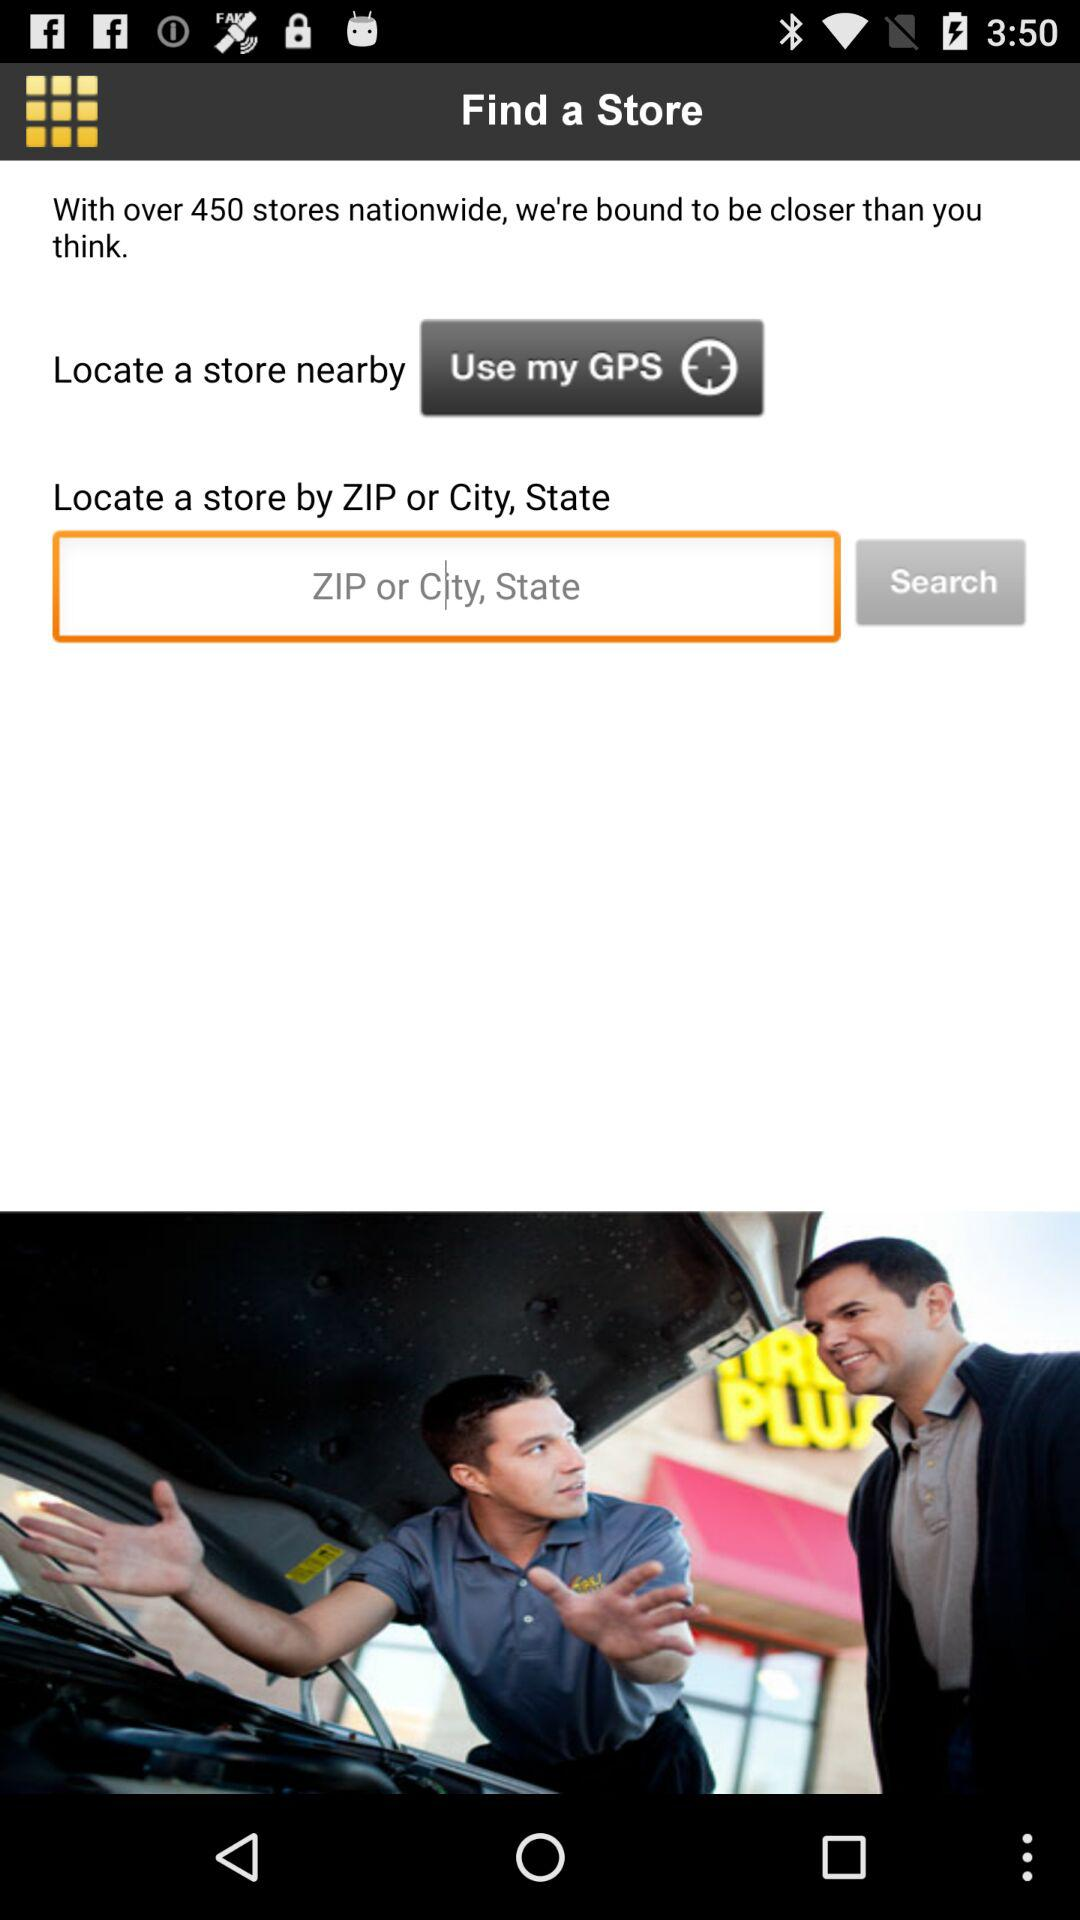What are the requirements to locate the store? The requirement is "Use my GPS" or "ZIP or City, State". 